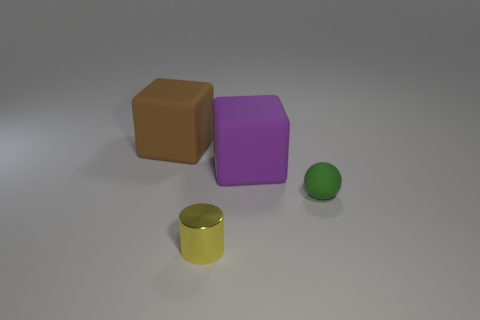There is a big purple rubber object that is on the right side of the yellow object; does it have the same shape as the green matte object?
Make the answer very short. No. How many objects are either big purple rubber objects or cubes to the left of the tiny yellow metal cylinder?
Make the answer very short. 2. Is the number of big rubber blocks that are right of the big brown matte object greater than the number of matte objects?
Provide a short and direct response. No. Is the number of big purple objects that are behind the small green object the same as the number of tiny cylinders that are on the left side of the brown rubber block?
Ensure brevity in your answer.  No. There is a large rubber block behind the big purple cube; is there a metallic object behind it?
Your answer should be very brief. No. The large purple object is what shape?
Provide a succinct answer. Cube. What size is the cube that is right of the big rubber thing behind the large purple rubber object?
Your response must be concise. Large. There is a object in front of the small green sphere; what size is it?
Make the answer very short. Small. Is the number of yellow cylinders that are right of the green sphere less than the number of yellow things that are behind the cylinder?
Make the answer very short. No. What color is the small ball?
Keep it short and to the point. Green. 